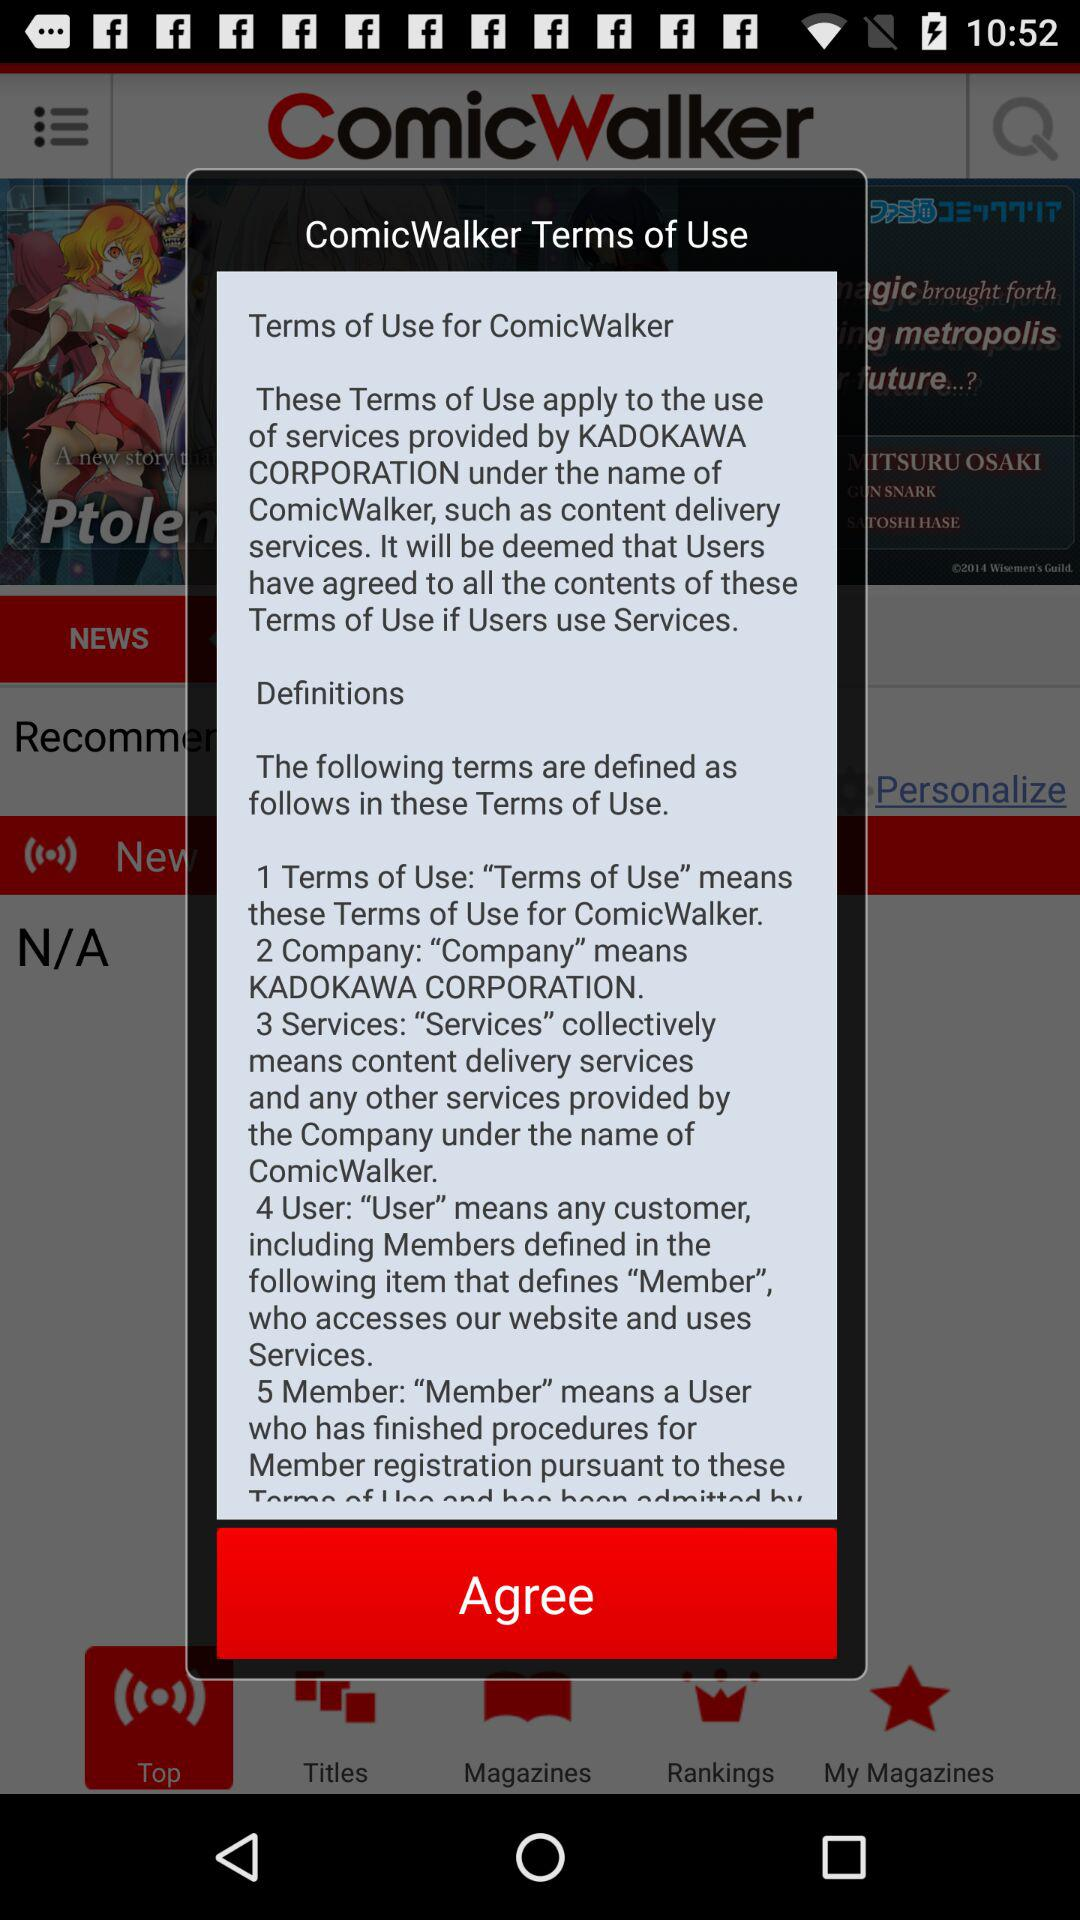What is the name of the application? The name of the application is "ComicWalker". 